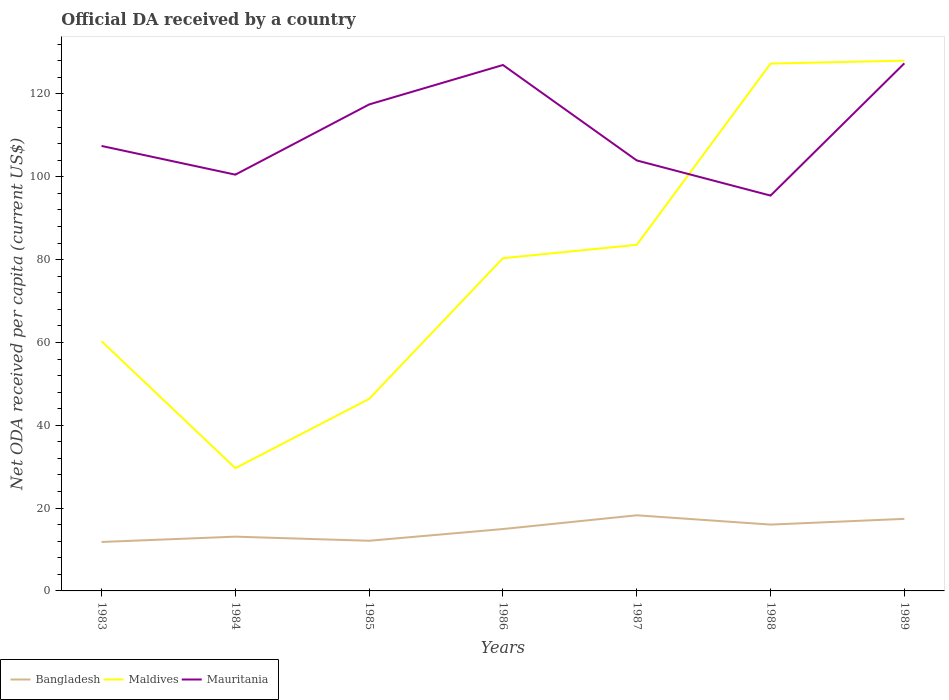How many different coloured lines are there?
Ensure brevity in your answer.  3. Is the number of lines equal to the number of legend labels?
Your answer should be compact. Yes. Across all years, what is the maximum ODA received in in Bangladesh?
Provide a succinct answer. 11.82. In which year was the ODA received in in Maldives maximum?
Ensure brevity in your answer.  1984. What is the total ODA received in in Maldives in the graph?
Offer a very short reply. -3.23. What is the difference between the highest and the second highest ODA received in in Maldives?
Offer a terse response. 98.41. What is the difference between the highest and the lowest ODA received in in Mauritania?
Provide a short and direct response. 3. Is the ODA received in in Mauritania strictly greater than the ODA received in in Maldives over the years?
Your response must be concise. No. Are the values on the major ticks of Y-axis written in scientific E-notation?
Your answer should be very brief. No. Does the graph contain grids?
Ensure brevity in your answer.  No. Where does the legend appear in the graph?
Your answer should be very brief. Bottom left. What is the title of the graph?
Your answer should be compact. Official DA received by a country. What is the label or title of the Y-axis?
Offer a terse response. Net ODA received per capita (current US$). What is the Net ODA received per capita (current US$) in Bangladesh in 1983?
Make the answer very short. 11.82. What is the Net ODA received per capita (current US$) in Maldives in 1983?
Offer a terse response. 60.31. What is the Net ODA received per capita (current US$) in Mauritania in 1983?
Ensure brevity in your answer.  107.45. What is the Net ODA received per capita (current US$) of Bangladesh in 1984?
Ensure brevity in your answer.  13.11. What is the Net ODA received per capita (current US$) of Maldives in 1984?
Offer a very short reply. 29.64. What is the Net ODA received per capita (current US$) in Mauritania in 1984?
Offer a terse response. 100.52. What is the Net ODA received per capita (current US$) of Bangladesh in 1985?
Make the answer very short. 12.11. What is the Net ODA received per capita (current US$) in Maldives in 1985?
Ensure brevity in your answer.  46.37. What is the Net ODA received per capita (current US$) of Mauritania in 1985?
Offer a very short reply. 117.47. What is the Net ODA received per capita (current US$) in Bangladesh in 1986?
Provide a succinct answer. 14.95. What is the Net ODA received per capita (current US$) of Maldives in 1986?
Your response must be concise. 80.34. What is the Net ODA received per capita (current US$) in Mauritania in 1986?
Your answer should be compact. 127. What is the Net ODA received per capita (current US$) in Bangladesh in 1987?
Keep it short and to the point. 18.26. What is the Net ODA received per capita (current US$) in Maldives in 1987?
Your answer should be compact. 83.57. What is the Net ODA received per capita (current US$) of Mauritania in 1987?
Provide a short and direct response. 103.95. What is the Net ODA received per capita (current US$) of Bangladesh in 1988?
Your response must be concise. 16.02. What is the Net ODA received per capita (current US$) in Maldives in 1988?
Give a very brief answer. 127.34. What is the Net ODA received per capita (current US$) in Mauritania in 1988?
Your answer should be compact. 95.46. What is the Net ODA received per capita (current US$) of Bangladesh in 1989?
Offer a very short reply. 17.4. What is the Net ODA received per capita (current US$) in Maldives in 1989?
Provide a succinct answer. 128.05. What is the Net ODA received per capita (current US$) in Mauritania in 1989?
Your response must be concise. 127.4. Across all years, what is the maximum Net ODA received per capita (current US$) in Bangladesh?
Your response must be concise. 18.26. Across all years, what is the maximum Net ODA received per capita (current US$) of Maldives?
Make the answer very short. 128.05. Across all years, what is the maximum Net ODA received per capita (current US$) in Mauritania?
Ensure brevity in your answer.  127.4. Across all years, what is the minimum Net ODA received per capita (current US$) in Bangladesh?
Offer a very short reply. 11.82. Across all years, what is the minimum Net ODA received per capita (current US$) in Maldives?
Offer a very short reply. 29.64. Across all years, what is the minimum Net ODA received per capita (current US$) in Mauritania?
Ensure brevity in your answer.  95.46. What is the total Net ODA received per capita (current US$) in Bangladesh in the graph?
Offer a very short reply. 103.67. What is the total Net ODA received per capita (current US$) of Maldives in the graph?
Keep it short and to the point. 555.63. What is the total Net ODA received per capita (current US$) in Mauritania in the graph?
Make the answer very short. 779.26. What is the difference between the Net ODA received per capita (current US$) of Bangladesh in 1983 and that in 1984?
Keep it short and to the point. -1.28. What is the difference between the Net ODA received per capita (current US$) of Maldives in 1983 and that in 1984?
Your answer should be compact. 30.67. What is the difference between the Net ODA received per capita (current US$) in Mauritania in 1983 and that in 1984?
Provide a short and direct response. 6.93. What is the difference between the Net ODA received per capita (current US$) in Bangladesh in 1983 and that in 1985?
Offer a very short reply. -0.29. What is the difference between the Net ODA received per capita (current US$) of Maldives in 1983 and that in 1985?
Keep it short and to the point. 13.94. What is the difference between the Net ODA received per capita (current US$) of Mauritania in 1983 and that in 1985?
Keep it short and to the point. -10.02. What is the difference between the Net ODA received per capita (current US$) in Bangladesh in 1983 and that in 1986?
Keep it short and to the point. -3.12. What is the difference between the Net ODA received per capita (current US$) in Maldives in 1983 and that in 1986?
Offer a terse response. -20.03. What is the difference between the Net ODA received per capita (current US$) in Mauritania in 1983 and that in 1986?
Ensure brevity in your answer.  -19.55. What is the difference between the Net ODA received per capita (current US$) in Bangladesh in 1983 and that in 1987?
Provide a succinct answer. -6.44. What is the difference between the Net ODA received per capita (current US$) of Maldives in 1983 and that in 1987?
Keep it short and to the point. -23.26. What is the difference between the Net ODA received per capita (current US$) in Mauritania in 1983 and that in 1987?
Your answer should be very brief. 3.5. What is the difference between the Net ODA received per capita (current US$) in Bangladesh in 1983 and that in 1988?
Your response must be concise. -4.2. What is the difference between the Net ODA received per capita (current US$) of Maldives in 1983 and that in 1988?
Provide a short and direct response. -67.03. What is the difference between the Net ODA received per capita (current US$) of Mauritania in 1983 and that in 1988?
Your answer should be very brief. 11.99. What is the difference between the Net ODA received per capita (current US$) of Bangladesh in 1983 and that in 1989?
Provide a short and direct response. -5.58. What is the difference between the Net ODA received per capita (current US$) in Maldives in 1983 and that in 1989?
Offer a terse response. -67.74. What is the difference between the Net ODA received per capita (current US$) in Mauritania in 1983 and that in 1989?
Offer a very short reply. -19.95. What is the difference between the Net ODA received per capita (current US$) of Bangladesh in 1984 and that in 1985?
Keep it short and to the point. 0.99. What is the difference between the Net ODA received per capita (current US$) in Maldives in 1984 and that in 1985?
Your response must be concise. -16.73. What is the difference between the Net ODA received per capita (current US$) in Mauritania in 1984 and that in 1985?
Ensure brevity in your answer.  -16.95. What is the difference between the Net ODA received per capita (current US$) of Bangladesh in 1984 and that in 1986?
Your response must be concise. -1.84. What is the difference between the Net ODA received per capita (current US$) of Maldives in 1984 and that in 1986?
Ensure brevity in your answer.  -50.7. What is the difference between the Net ODA received per capita (current US$) in Mauritania in 1984 and that in 1986?
Offer a terse response. -26.48. What is the difference between the Net ODA received per capita (current US$) of Bangladesh in 1984 and that in 1987?
Ensure brevity in your answer.  -5.16. What is the difference between the Net ODA received per capita (current US$) of Maldives in 1984 and that in 1987?
Provide a succinct answer. -53.93. What is the difference between the Net ODA received per capita (current US$) of Mauritania in 1984 and that in 1987?
Your answer should be compact. -3.43. What is the difference between the Net ODA received per capita (current US$) of Bangladesh in 1984 and that in 1988?
Give a very brief answer. -2.91. What is the difference between the Net ODA received per capita (current US$) of Maldives in 1984 and that in 1988?
Offer a very short reply. -97.7. What is the difference between the Net ODA received per capita (current US$) in Mauritania in 1984 and that in 1988?
Keep it short and to the point. 5.06. What is the difference between the Net ODA received per capita (current US$) in Bangladesh in 1984 and that in 1989?
Ensure brevity in your answer.  -4.3. What is the difference between the Net ODA received per capita (current US$) of Maldives in 1984 and that in 1989?
Give a very brief answer. -98.41. What is the difference between the Net ODA received per capita (current US$) of Mauritania in 1984 and that in 1989?
Your response must be concise. -26.88. What is the difference between the Net ODA received per capita (current US$) of Bangladesh in 1985 and that in 1986?
Ensure brevity in your answer.  -2.83. What is the difference between the Net ODA received per capita (current US$) in Maldives in 1985 and that in 1986?
Provide a succinct answer. -33.97. What is the difference between the Net ODA received per capita (current US$) in Mauritania in 1985 and that in 1986?
Your response must be concise. -9.52. What is the difference between the Net ODA received per capita (current US$) of Bangladesh in 1985 and that in 1987?
Keep it short and to the point. -6.15. What is the difference between the Net ODA received per capita (current US$) of Maldives in 1985 and that in 1987?
Your response must be concise. -37.2. What is the difference between the Net ODA received per capita (current US$) in Mauritania in 1985 and that in 1987?
Provide a succinct answer. 13.52. What is the difference between the Net ODA received per capita (current US$) of Bangladesh in 1985 and that in 1988?
Offer a very short reply. -3.91. What is the difference between the Net ODA received per capita (current US$) in Maldives in 1985 and that in 1988?
Keep it short and to the point. -80.97. What is the difference between the Net ODA received per capita (current US$) of Mauritania in 1985 and that in 1988?
Offer a terse response. 22.01. What is the difference between the Net ODA received per capita (current US$) of Bangladesh in 1985 and that in 1989?
Provide a short and direct response. -5.29. What is the difference between the Net ODA received per capita (current US$) in Maldives in 1985 and that in 1989?
Make the answer very short. -81.68. What is the difference between the Net ODA received per capita (current US$) of Mauritania in 1985 and that in 1989?
Your response must be concise. -9.93. What is the difference between the Net ODA received per capita (current US$) in Bangladesh in 1986 and that in 1987?
Your answer should be compact. -3.32. What is the difference between the Net ODA received per capita (current US$) in Maldives in 1986 and that in 1987?
Your answer should be compact. -3.23. What is the difference between the Net ODA received per capita (current US$) in Mauritania in 1986 and that in 1987?
Offer a very short reply. 23.05. What is the difference between the Net ODA received per capita (current US$) in Bangladesh in 1986 and that in 1988?
Provide a short and direct response. -1.07. What is the difference between the Net ODA received per capita (current US$) of Maldives in 1986 and that in 1988?
Your answer should be compact. -47. What is the difference between the Net ODA received per capita (current US$) of Mauritania in 1986 and that in 1988?
Provide a succinct answer. 31.54. What is the difference between the Net ODA received per capita (current US$) of Bangladesh in 1986 and that in 1989?
Keep it short and to the point. -2.46. What is the difference between the Net ODA received per capita (current US$) in Maldives in 1986 and that in 1989?
Your answer should be compact. -47.71. What is the difference between the Net ODA received per capita (current US$) of Mauritania in 1986 and that in 1989?
Your response must be concise. -0.4. What is the difference between the Net ODA received per capita (current US$) in Bangladesh in 1987 and that in 1988?
Offer a very short reply. 2.25. What is the difference between the Net ODA received per capita (current US$) of Maldives in 1987 and that in 1988?
Keep it short and to the point. -43.77. What is the difference between the Net ODA received per capita (current US$) in Mauritania in 1987 and that in 1988?
Offer a terse response. 8.49. What is the difference between the Net ODA received per capita (current US$) in Bangladesh in 1987 and that in 1989?
Give a very brief answer. 0.86. What is the difference between the Net ODA received per capita (current US$) of Maldives in 1987 and that in 1989?
Ensure brevity in your answer.  -44.48. What is the difference between the Net ODA received per capita (current US$) of Mauritania in 1987 and that in 1989?
Provide a short and direct response. -23.45. What is the difference between the Net ODA received per capita (current US$) in Bangladesh in 1988 and that in 1989?
Your response must be concise. -1.38. What is the difference between the Net ODA received per capita (current US$) in Maldives in 1988 and that in 1989?
Ensure brevity in your answer.  -0.71. What is the difference between the Net ODA received per capita (current US$) of Mauritania in 1988 and that in 1989?
Your answer should be very brief. -31.94. What is the difference between the Net ODA received per capita (current US$) of Bangladesh in 1983 and the Net ODA received per capita (current US$) of Maldives in 1984?
Make the answer very short. -17.82. What is the difference between the Net ODA received per capita (current US$) of Bangladesh in 1983 and the Net ODA received per capita (current US$) of Mauritania in 1984?
Keep it short and to the point. -88.7. What is the difference between the Net ODA received per capita (current US$) in Maldives in 1983 and the Net ODA received per capita (current US$) in Mauritania in 1984?
Your response must be concise. -40.21. What is the difference between the Net ODA received per capita (current US$) of Bangladesh in 1983 and the Net ODA received per capita (current US$) of Maldives in 1985?
Ensure brevity in your answer.  -34.55. What is the difference between the Net ODA received per capita (current US$) of Bangladesh in 1983 and the Net ODA received per capita (current US$) of Mauritania in 1985?
Offer a terse response. -105.65. What is the difference between the Net ODA received per capita (current US$) in Maldives in 1983 and the Net ODA received per capita (current US$) in Mauritania in 1985?
Make the answer very short. -57.16. What is the difference between the Net ODA received per capita (current US$) of Bangladesh in 1983 and the Net ODA received per capita (current US$) of Maldives in 1986?
Provide a succinct answer. -68.52. What is the difference between the Net ODA received per capita (current US$) of Bangladesh in 1983 and the Net ODA received per capita (current US$) of Mauritania in 1986?
Your response must be concise. -115.18. What is the difference between the Net ODA received per capita (current US$) in Maldives in 1983 and the Net ODA received per capita (current US$) in Mauritania in 1986?
Keep it short and to the point. -66.69. What is the difference between the Net ODA received per capita (current US$) in Bangladesh in 1983 and the Net ODA received per capita (current US$) in Maldives in 1987?
Give a very brief answer. -71.75. What is the difference between the Net ODA received per capita (current US$) in Bangladesh in 1983 and the Net ODA received per capita (current US$) in Mauritania in 1987?
Give a very brief answer. -92.13. What is the difference between the Net ODA received per capita (current US$) in Maldives in 1983 and the Net ODA received per capita (current US$) in Mauritania in 1987?
Your response must be concise. -43.64. What is the difference between the Net ODA received per capita (current US$) in Bangladesh in 1983 and the Net ODA received per capita (current US$) in Maldives in 1988?
Provide a succinct answer. -115.52. What is the difference between the Net ODA received per capita (current US$) in Bangladesh in 1983 and the Net ODA received per capita (current US$) in Mauritania in 1988?
Your response must be concise. -83.64. What is the difference between the Net ODA received per capita (current US$) of Maldives in 1983 and the Net ODA received per capita (current US$) of Mauritania in 1988?
Ensure brevity in your answer.  -35.15. What is the difference between the Net ODA received per capita (current US$) of Bangladesh in 1983 and the Net ODA received per capita (current US$) of Maldives in 1989?
Your response must be concise. -116.23. What is the difference between the Net ODA received per capita (current US$) of Bangladesh in 1983 and the Net ODA received per capita (current US$) of Mauritania in 1989?
Your answer should be compact. -115.58. What is the difference between the Net ODA received per capita (current US$) in Maldives in 1983 and the Net ODA received per capita (current US$) in Mauritania in 1989?
Give a very brief answer. -67.09. What is the difference between the Net ODA received per capita (current US$) of Bangladesh in 1984 and the Net ODA received per capita (current US$) of Maldives in 1985?
Offer a very short reply. -33.27. What is the difference between the Net ODA received per capita (current US$) of Bangladesh in 1984 and the Net ODA received per capita (current US$) of Mauritania in 1985?
Your response must be concise. -104.37. What is the difference between the Net ODA received per capita (current US$) of Maldives in 1984 and the Net ODA received per capita (current US$) of Mauritania in 1985?
Your answer should be compact. -87.83. What is the difference between the Net ODA received per capita (current US$) of Bangladesh in 1984 and the Net ODA received per capita (current US$) of Maldives in 1986?
Your response must be concise. -67.24. What is the difference between the Net ODA received per capita (current US$) of Bangladesh in 1984 and the Net ODA received per capita (current US$) of Mauritania in 1986?
Give a very brief answer. -113.89. What is the difference between the Net ODA received per capita (current US$) of Maldives in 1984 and the Net ODA received per capita (current US$) of Mauritania in 1986?
Your answer should be very brief. -97.36. What is the difference between the Net ODA received per capita (current US$) of Bangladesh in 1984 and the Net ODA received per capita (current US$) of Maldives in 1987?
Your answer should be very brief. -70.47. What is the difference between the Net ODA received per capita (current US$) in Bangladesh in 1984 and the Net ODA received per capita (current US$) in Mauritania in 1987?
Provide a short and direct response. -90.85. What is the difference between the Net ODA received per capita (current US$) of Maldives in 1984 and the Net ODA received per capita (current US$) of Mauritania in 1987?
Give a very brief answer. -74.31. What is the difference between the Net ODA received per capita (current US$) of Bangladesh in 1984 and the Net ODA received per capita (current US$) of Maldives in 1988?
Your answer should be compact. -114.23. What is the difference between the Net ODA received per capita (current US$) of Bangladesh in 1984 and the Net ODA received per capita (current US$) of Mauritania in 1988?
Your response must be concise. -82.36. What is the difference between the Net ODA received per capita (current US$) of Maldives in 1984 and the Net ODA received per capita (current US$) of Mauritania in 1988?
Your response must be concise. -65.82. What is the difference between the Net ODA received per capita (current US$) in Bangladesh in 1984 and the Net ODA received per capita (current US$) in Maldives in 1989?
Offer a terse response. -114.95. What is the difference between the Net ODA received per capita (current US$) of Bangladesh in 1984 and the Net ODA received per capita (current US$) of Mauritania in 1989?
Offer a terse response. -114.3. What is the difference between the Net ODA received per capita (current US$) of Maldives in 1984 and the Net ODA received per capita (current US$) of Mauritania in 1989?
Keep it short and to the point. -97.76. What is the difference between the Net ODA received per capita (current US$) in Bangladesh in 1985 and the Net ODA received per capita (current US$) in Maldives in 1986?
Provide a short and direct response. -68.23. What is the difference between the Net ODA received per capita (current US$) of Bangladesh in 1985 and the Net ODA received per capita (current US$) of Mauritania in 1986?
Keep it short and to the point. -114.89. What is the difference between the Net ODA received per capita (current US$) of Maldives in 1985 and the Net ODA received per capita (current US$) of Mauritania in 1986?
Keep it short and to the point. -80.63. What is the difference between the Net ODA received per capita (current US$) of Bangladesh in 1985 and the Net ODA received per capita (current US$) of Maldives in 1987?
Provide a succinct answer. -71.46. What is the difference between the Net ODA received per capita (current US$) in Bangladesh in 1985 and the Net ODA received per capita (current US$) in Mauritania in 1987?
Your answer should be very brief. -91.84. What is the difference between the Net ODA received per capita (current US$) in Maldives in 1985 and the Net ODA received per capita (current US$) in Mauritania in 1987?
Ensure brevity in your answer.  -57.58. What is the difference between the Net ODA received per capita (current US$) of Bangladesh in 1985 and the Net ODA received per capita (current US$) of Maldives in 1988?
Your response must be concise. -115.23. What is the difference between the Net ODA received per capita (current US$) in Bangladesh in 1985 and the Net ODA received per capita (current US$) in Mauritania in 1988?
Your response must be concise. -83.35. What is the difference between the Net ODA received per capita (current US$) in Maldives in 1985 and the Net ODA received per capita (current US$) in Mauritania in 1988?
Provide a succinct answer. -49.09. What is the difference between the Net ODA received per capita (current US$) of Bangladesh in 1985 and the Net ODA received per capita (current US$) of Maldives in 1989?
Give a very brief answer. -115.94. What is the difference between the Net ODA received per capita (current US$) in Bangladesh in 1985 and the Net ODA received per capita (current US$) in Mauritania in 1989?
Your answer should be compact. -115.29. What is the difference between the Net ODA received per capita (current US$) of Maldives in 1985 and the Net ODA received per capita (current US$) of Mauritania in 1989?
Your response must be concise. -81.03. What is the difference between the Net ODA received per capita (current US$) of Bangladesh in 1986 and the Net ODA received per capita (current US$) of Maldives in 1987?
Your answer should be very brief. -68.63. What is the difference between the Net ODA received per capita (current US$) in Bangladesh in 1986 and the Net ODA received per capita (current US$) in Mauritania in 1987?
Ensure brevity in your answer.  -89.01. What is the difference between the Net ODA received per capita (current US$) in Maldives in 1986 and the Net ODA received per capita (current US$) in Mauritania in 1987?
Keep it short and to the point. -23.61. What is the difference between the Net ODA received per capita (current US$) of Bangladesh in 1986 and the Net ODA received per capita (current US$) of Maldives in 1988?
Your answer should be very brief. -112.39. What is the difference between the Net ODA received per capita (current US$) in Bangladesh in 1986 and the Net ODA received per capita (current US$) in Mauritania in 1988?
Offer a very short reply. -80.52. What is the difference between the Net ODA received per capita (current US$) in Maldives in 1986 and the Net ODA received per capita (current US$) in Mauritania in 1988?
Offer a terse response. -15.12. What is the difference between the Net ODA received per capita (current US$) of Bangladesh in 1986 and the Net ODA received per capita (current US$) of Maldives in 1989?
Offer a very short reply. -113.11. What is the difference between the Net ODA received per capita (current US$) in Bangladesh in 1986 and the Net ODA received per capita (current US$) in Mauritania in 1989?
Keep it short and to the point. -112.46. What is the difference between the Net ODA received per capita (current US$) in Maldives in 1986 and the Net ODA received per capita (current US$) in Mauritania in 1989?
Your response must be concise. -47.06. What is the difference between the Net ODA received per capita (current US$) in Bangladesh in 1987 and the Net ODA received per capita (current US$) in Maldives in 1988?
Make the answer very short. -109.08. What is the difference between the Net ODA received per capita (current US$) in Bangladesh in 1987 and the Net ODA received per capita (current US$) in Mauritania in 1988?
Your answer should be compact. -77.2. What is the difference between the Net ODA received per capita (current US$) in Maldives in 1987 and the Net ODA received per capita (current US$) in Mauritania in 1988?
Make the answer very short. -11.89. What is the difference between the Net ODA received per capita (current US$) of Bangladesh in 1987 and the Net ODA received per capita (current US$) of Maldives in 1989?
Keep it short and to the point. -109.79. What is the difference between the Net ODA received per capita (current US$) in Bangladesh in 1987 and the Net ODA received per capita (current US$) in Mauritania in 1989?
Give a very brief answer. -109.14. What is the difference between the Net ODA received per capita (current US$) in Maldives in 1987 and the Net ODA received per capita (current US$) in Mauritania in 1989?
Provide a succinct answer. -43.83. What is the difference between the Net ODA received per capita (current US$) in Bangladesh in 1988 and the Net ODA received per capita (current US$) in Maldives in 1989?
Make the answer very short. -112.03. What is the difference between the Net ODA received per capita (current US$) of Bangladesh in 1988 and the Net ODA received per capita (current US$) of Mauritania in 1989?
Your answer should be compact. -111.38. What is the difference between the Net ODA received per capita (current US$) of Maldives in 1988 and the Net ODA received per capita (current US$) of Mauritania in 1989?
Your answer should be compact. -0.06. What is the average Net ODA received per capita (current US$) of Bangladesh per year?
Ensure brevity in your answer.  14.81. What is the average Net ODA received per capita (current US$) of Maldives per year?
Provide a succinct answer. 79.38. What is the average Net ODA received per capita (current US$) in Mauritania per year?
Your response must be concise. 111.32. In the year 1983, what is the difference between the Net ODA received per capita (current US$) in Bangladesh and Net ODA received per capita (current US$) in Maldives?
Keep it short and to the point. -48.49. In the year 1983, what is the difference between the Net ODA received per capita (current US$) in Bangladesh and Net ODA received per capita (current US$) in Mauritania?
Your response must be concise. -95.63. In the year 1983, what is the difference between the Net ODA received per capita (current US$) in Maldives and Net ODA received per capita (current US$) in Mauritania?
Make the answer very short. -47.14. In the year 1984, what is the difference between the Net ODA received per capita (current US$) of Bangladesh and Net ODA received per capita (current US$) of Maldives?
Ensure brevity in your answer.  -16.53. In the year 1984, what is the difference between the Net ODA received per capita (current US$) of Bangladesh and Net ODA received per capita (current US$) of Mauritania?
Provide a short and direct response. -87.42. In the year 1984, what is the difference between the Net ODA received per capita (current US$) of Maldives and Net ODA received per capita (current US$) of Mauritania?
Offer a very short reply. -70.88. In the year 1985, what is the difference between the Net ODA received per capita (current US$) in Bangladesh and Net ODA received per capita (current US$) in Maldives?
Provide a succinct answer. -34.26. In the year 1985, what is the difference between the Net ODA received per capita (current US$) of Bangladesh and Net ODA received per capita (current US$) of Mauritania?
Offer a very short reply. -105.36. In the year 1985, what is the difference between the Net ODA received per capita (current US$) of Maldives and Net ODA received per capita (current US$) of Mauritania?
Offer a terse response. -71.1. In the year 1986, what is the difference between the Net ODA received per capita (current US$) of Bangladesh and Net ODA received per capita (current US$) of Maldives?
Keep it short and to the point. -65.4. In the year 1986, what is the difference between the Net ODA received per capita (current US$) of Bangladesh and Net ODA received per capita (current US$) of Mauritania?
Ensure brevity in your answer.  -112.05. In the year 1986, what is the difference between the Net ODA received per capita (current US$) of Maldives and Net ODA received per capita (current US$) of Mauritania?
Your answer should be compact. -46.66. In the year 1987, what is the difference between the Net ODA received per capita (current US$) in Bangladesh and Net ODA received per capita (current US$) in Maldives?
Your response must be concise. -65.31. In the year 1987, what is the difference between the Net ODA received per capita (current US$) in Bangladesh and Net ODA received per capita (current US$) in Mauritania?
Offer a very short reply. -85.69. In the year 1987, what is the difference between the Net ODA received per capita (current US$) in Maldives and Net ODA received per capita (current US$) in Mauritania?
Your answer should be very brief. -20.38. In the year 1988, what is the difference between the Net ODA received per capita (current US$) of Bangladesh and Net ODA received per capita (current US$) of Maldives?
Your answer should be very brief. -111.32. In the year 1988, what is the difference between the Net ODA received per capita (current US$) in Bangladesh and Net ODA received per capita (current US$) in Mauritania?
Your response must be concise. -79.44. In the year 1988, what is the difference between the Net ODA received per capita (current US$) in Maldives and Net ODA received per capita (current US$) in Mauritania?
Provide a succinct answer. 31.88. In the year 1989, what is the difference between the Net ODA received per capita (current US$) in Bangladesh and Net ODA received per capita (current US$) in Maldives?
Your response must be concise. -110.65. In the year 1989, what is the difference between the Net ODA received per capita (current US$) of Bangladesh and Net ODA received per capita (current US$) of Mauritania?
Provide a succinct answer. -110. In the year 1989, what is the difference between the Net ODA received per capita (current US$) of Maldives and Net ODA received per capita (current US$) of Mauritania?
Offer a very short reply. 0.65. What is the ratio of the Net ODA received per capita (current US$) of Bangladesh in 1983 to that in 1984?
Provide a succinct answer. 0.9. What is the ratio of the Net ODA received per capita (current US$) in Maldives in 1983 to that in 1984?
Make the answer very short. 2.03. What is the ratio of the Net ODA received per capita (current US$) of Mauritania in 1983 to that in 1984?
Your response must be concise. 1.07. What is the ratio of the Net ODA received per capita (current US$) of Bangladesh in 1983 to that in 1985?
Your answer should be compact. 0.98. What is the ratio of the Net ODA received per capita (current US$) in Maldives in 1983 to that in 1985?
Keep it short and to the point. 1.3. What is the ratio of the Net ODA received per capita (current US$) of Mauritania in 1983 to that in 1985?
Offer a terse response. 0.91. What is the ratio of the Net ODA received per capita (current US$) of Bangladesh in 1983 to that in 1986?
Your answer should be compact. 0.79. What is the ratio of the Net ODA received per capita (current US$) in Maldives in 1983 to that in 1986?
Provide a succinct answer. 0.75. What is the ratio of the Net ODA received per capita (current US$) of Mauritania in 1983 to that in 1986?
Provide a succinct answer. 0.85. What is the ratio of the Net ODA received per capita (current US$) of Bangladesh in 1983 to that in 1987?
Your answer should be very brief. 0.65. What is the ratio of the Net ODA received per capita (current US$) in Maldives in 1983 to that in 1987?
Provide a succinct answer. 0.72. What is the ratio of the Net ODA received per capita (current US$) in Mauritania in 1983 to that in 1987?
Ensure brevity in your answer.  1.03. What is the ratio of the Net ODA received per capita (current US$) of Bangladesh in 1983 to that in 1988?
Keep it short and to the point. 0.74. What is the ratio of the Net ODA received per capita (current US$) of Maldives in 1983 to that in 1988?
Ensure brevity in your answer.  0.47. What is the ratio of the Net ODA received per capita (current US$) in Mauritania in 1983 to that in 1988?
Ensure brevity in your answer.  1.13. What is the ratio of the Net ODA received per capita (current US$) in Bangladesh in 1983 to that in 1989?
Provide a succinct answer. 0.68. What is the ratio of the Net ODA received per capita (current US$) in Maldives in 1983 to that in 1989?
Your answer should be very brief. 0.47. What is the ratio of the Net ODA received per capita (current US$) of Mauritania in 1983 to that in 1989?
Provide a short and direct response. 0.84. What is the ratio of the Net ODA received per capita (current US$) of Bangladesh in 1984 to that in 1985?
Offer a terse response. 1.08. What is the ratio of the Net ODA received per capita (current US$) of Maldives in 1984 to that in 1985?
Your response must be concise. 0.64. What is the ratio of the Net ODA received per capita (current US$) of Mauritania in 1984 to that in 1985?
Your response must be concise. 0.86. What is the ratio of the Net ODA received per capita (current US$) of Bangladesh in 1984 to that in 1986?
Provide a short and direct response. 0.88. What is the ratio of the Net ODA received per capita (current US$) in Maldives in 1984 to that in 1986?
Your answer should be compact. 0.37. What is the ratio of the Net ODA received per capita (current US$) in Mauritania in 1984 to that in 1986?
Make the answer very short. 0.79. What is the ratio of the Net ODA received per capita (current US$) of Bangladesh in 1984 to that in 1987?
Offer a terse response. 0.72. What is the ratio of the Net ODA received per capita (current US$) of Maldives in 1984 to that in 1987?
Make the answer very short. 0.35. What is the ratio of the Net ODA received per capita (current US$) in Bangladesh in 1984 to that in 1988?
Make the answer very short. 0.82. What is the ratio of the Net ODA received per capita (current US$) of Maldives in 1984 to that in 1988?
Provide a succinct answer. 0.23. What is the ratio of the Net ODA received per capita (current US$) of Mauritania in 1984 to that in 1988?
Your response must be concise. 1.05. What is the ratio of the Net ODA received per capita (current US$) of Bangladesh in 1984 to that in 1989?
Your response must be concise. 0.75. What is the ratio of the Net ODA received per capita (current US$) of Maldives in 1984 to that in 1989?
Provide a short and direct response. 0.23. What is the ratio of the Net ODA received per capita (current US$) in Mauritania in 1984 to that in 1989?
Your answer should be very brief. 0.79. What is the ratio of the Net ODA received per capita (current US$) in Bangladesh in 1985 to that in 1986?
Your answer should be compact. 0.81. What is the ratio of the Net ODA received per capita (current US$) of Maldives in 1985 to that in 1986?
Your response must be concise. 0.58. What is the ratio of the Net ODA received per capita (current US$) in Mauritania in 1985 to that in 1986?
Provide a succinct answer. 0.93. What is the ratio of the Net ODA received per capita (current US$) of Bangladesh in 1985 to that in 1987?
Provide a short and direct response. 0.66. What is the ratio of the Net ODA received per capita (current US$) of Maldives in 1985 to that in 1987?
Your answer should be compact. 0.55. What is the ratio of the Net ODA received per capita (current US$) of Mauritania in 1985 to that in 1987?
Your answer should be very brief. 1.13. What is the ratio of the Net ODA received per capita (current US$) of Bangladesh in 1985 to that in 1988?
Provide a short and direct response. 0.76. What is the ratio of the Net ODA received per capita (current US$) of Maldives in 1985 to that in 1988?
Offer a very short reply. 0.36. What is the ratio of the Net ODA received per capita (current US$) of Mauritania in 1985 to that in 1988?
Your response must be concise. 1.23. What is the ratio of the Net ODA received per capita (current US$) of Bangladesh in 1985 to that in 1989?
Offer a very short reply. 0.7. What is the ratio of the Net ODA received per capita (current US$) in Maldives in 1985 to that in 1989?
Make the answer very short. 0.36. What is the ratio of the Net ODA received per capita (current US$) of Mauritania in 1985 to that in 1989?
Ensure brevity in your answer.  0.92. What is the ratio of the Net ODA received per capita (current US$) in Bangladesh in 1986 to that in 1987?
Make the answer very short. 0.82. What is the ratio of the Net ODA received per capita (current US$) of Maldives in 1986 to that in 1987?
Provide a succinct answer. 0.96. What is the ratio of the Net ODA received per capita (current US$) of Mauritania in 1986 to that in 1987?
Your answer should be very brief. 1.22. What is the ratio of the Net ODA received per capita (current US$) of Bangladesh in 1986 to that in 1988?
Offer a terse response. 0.93. What is the ratio of the Net ODA received per capita (current US$) in Maldives in 1986 to that in 1988?
Ensure brevity in your answer.  0.63. What is the ratio of the Net ODA received per capita (current US$) of Mauritania in 1986 to that in 1988?
Give a very brief answer. 1.33. What is the ratio of the Net ODA received per capita (current US$) in Bangladesh in 1986 to that in 1989?
Offer a very short reply. 0.86. What is the ratio of the Net ODA received per capita (current US$) in Maldives in 1986 to that in 1989?
Give a very brief answer. 0.63. What is the ratio of the Net ODA received per capita (current US$) of Mauritania in 1986 to that in 1989?
Your answer should be compact. 1. What is the ratio of the Net ODA received per capita (current US$) in Bangladesh in 1987 to that in 1988?
Your answer should be compact. 1.14. What is the ratio of the Net ODA received per capita (current US$) in Maldives in 1987 to that in 1988?
Give a very brief answer. 0.66. What is the ratio of the Net ODA received per capita (current US$) of Mauritania in 1987 to that in 1988?
Your response must be concise. 1.09. What is the ratio of the Net ODA received per capita (current US$) in Bangladesh in 1987 to that in 1989?
Make the answer very short. 1.05. What is the ratio of the Net ODA received per capita (current US$) in Maldives in 1987 to that in 1989?
Offer a terse response. 0.65. What is the ratio of the Net ODA received per capita (current US$) of Mauritania in 1987 to that in 1989?
Keep it short and to the point. 0.82. What is the ratio of the Net ODA received per capita (current US$) of Bangladesh in 1988 to that in 1989?
Offer a very short reply. 0.92. What is the ratio of the Net ODA received per capita (current US$) of Mauritania in 1988 to that in 1989?
Offer a very short reply. 0.75. What is the difference between the highest and the second highest Net ODA received per capita (current US$) of Bangladesh?
Make the answer very short. 0.86. What is the difference between the highest and the second highest Net ODA received per capita (current US$) of Maldives?
Your answer should be compact. 0.71. What is the difference between the highest and the second highest Net ODA received per capita (current US$) in Mauritania?
Offer a terse response. 0.4. What is the difference between the highest and the lowest Net ODA received per capita (current US$) of Bangladesh?
Give a very brief answer. 6.44. What is the difference between the highest and the lowest Net ODA received per capita (current US$) in Maldives?
Your response must be concise. 98.41. What is the difference between the highest and the lowest Net ODA received per capita (current US$) in Mauritania?
Offer a very short reply. 31.94. 